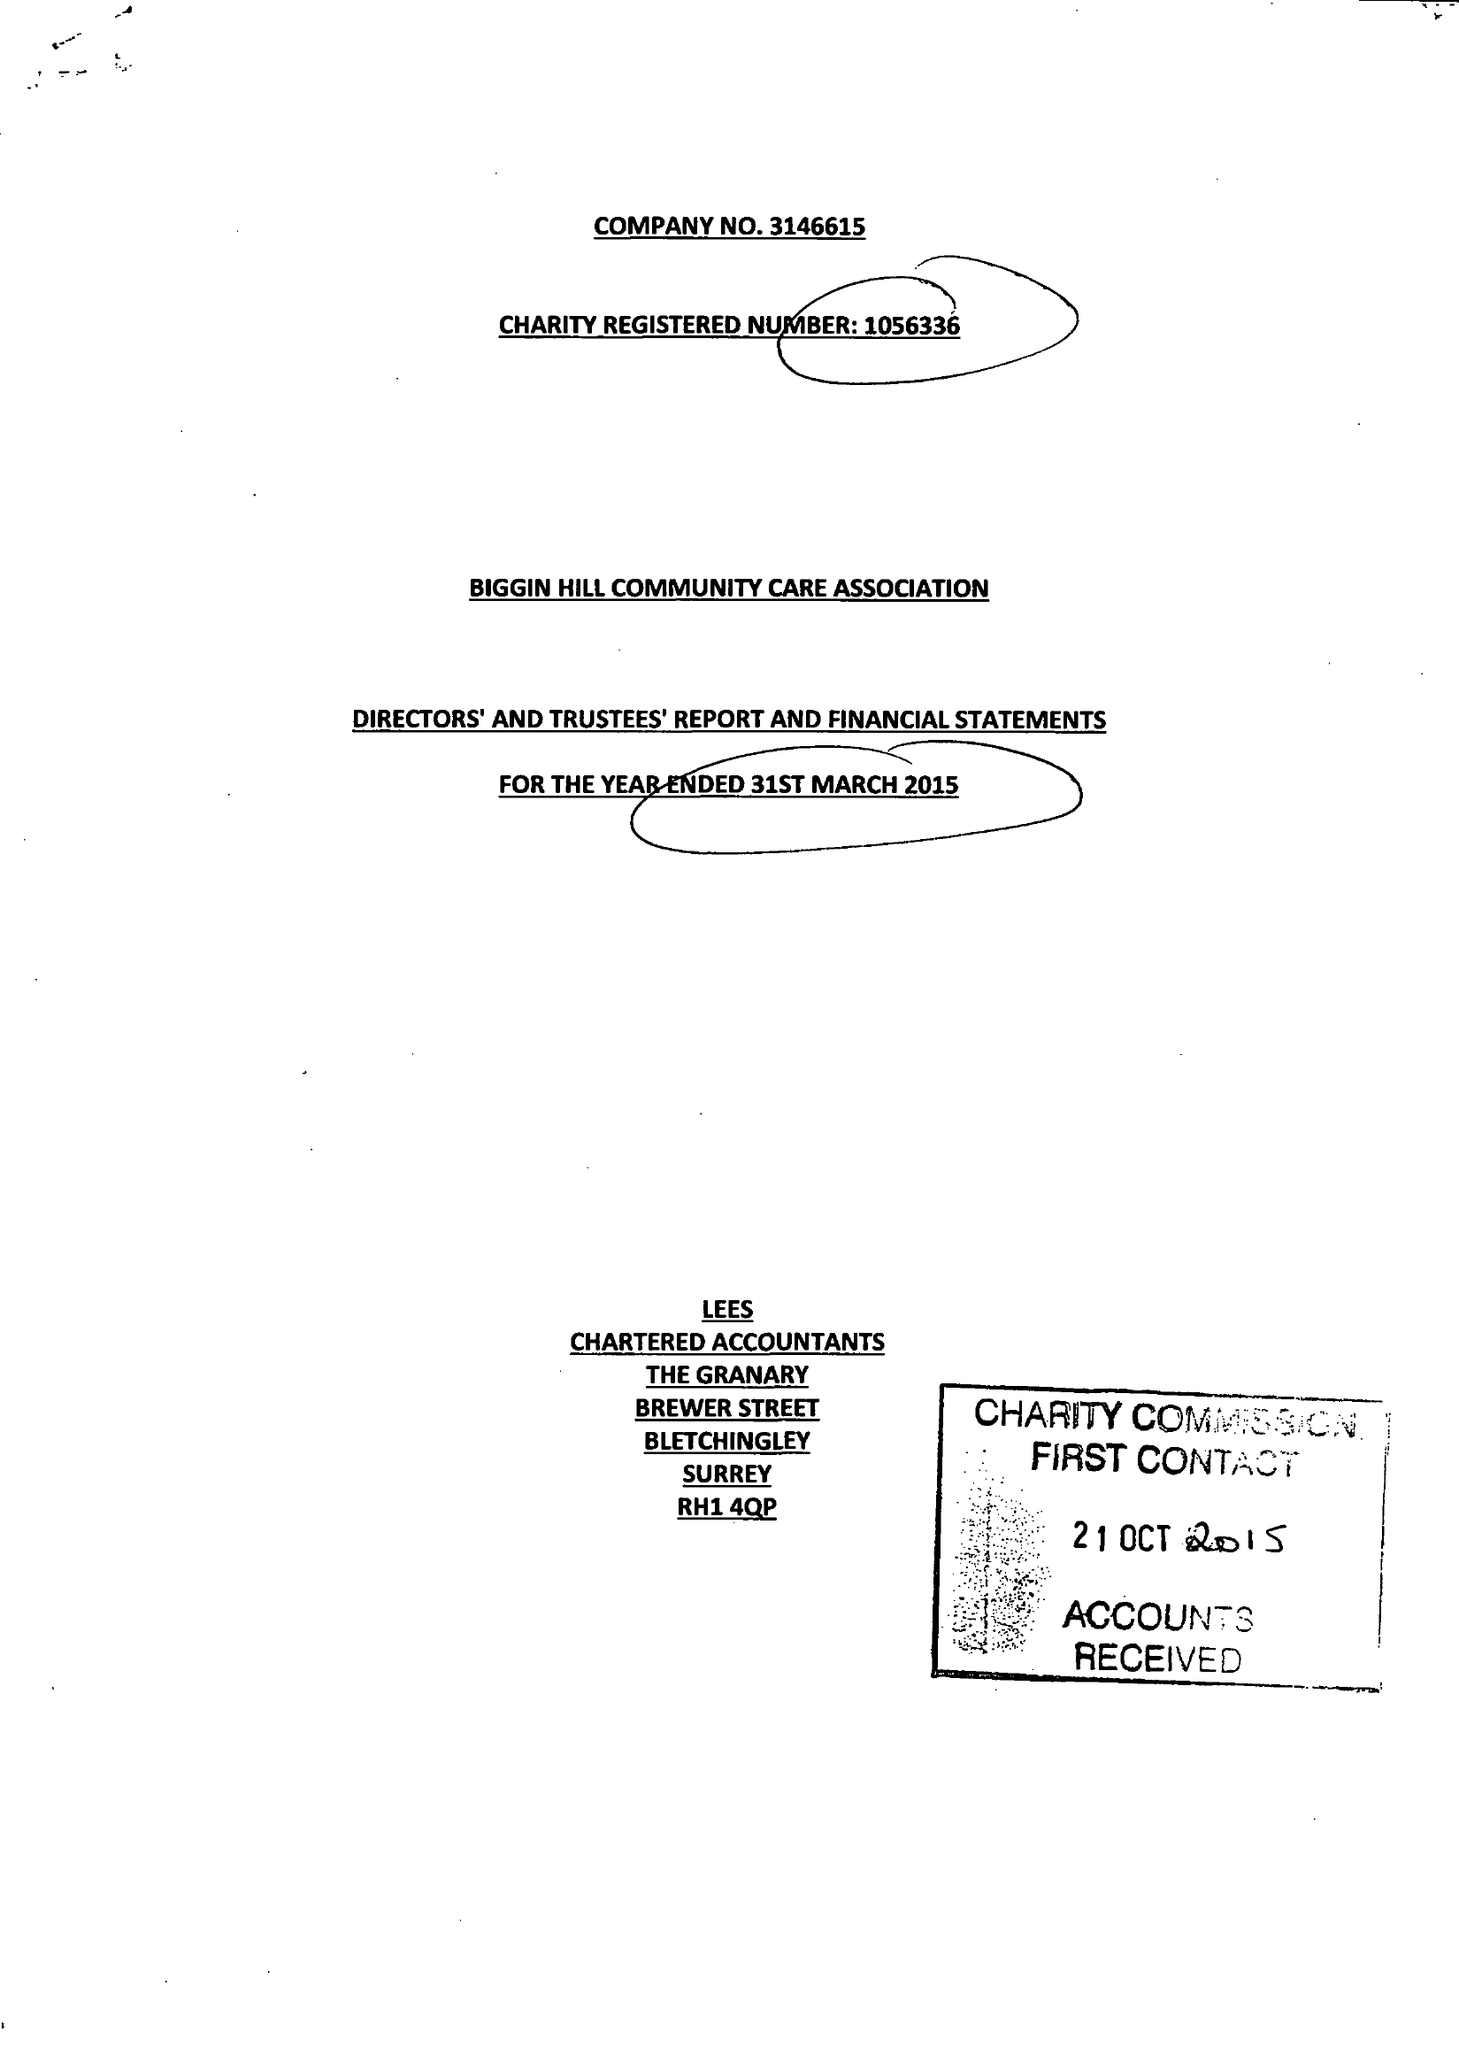What is the value for the address__postcode?
Answer the question using a single word or phrase. TN16 3LB 